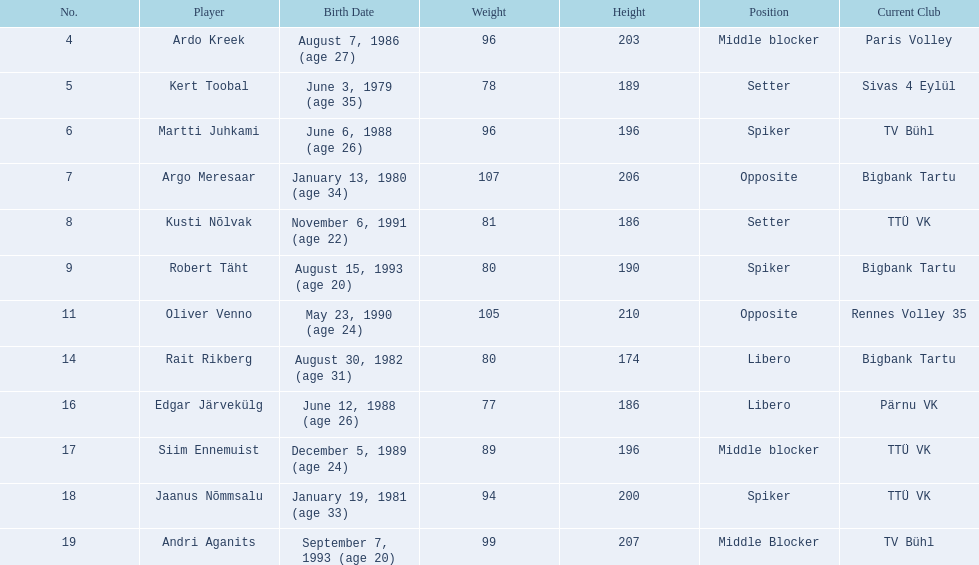Who comprises the estonian men's national volleyball team? Ardo Kreek, Kert Toobal, Martti Juhkami, Argo Meresaar, Kusti Nõlvak, Robert Täht, Oliver Venno, Rait Rikberg, Edgar Järvekülg, Siim Ennemuist, Jaanus Nõmmsalu, Andri Aganits. From these players, who has a height exceeding 200 cm? Ardo Kreek, Argo Meresaar, Oliver Venno, Andri Aganits. Of the remaining players, who stands the tallest? Oliver Venno. 